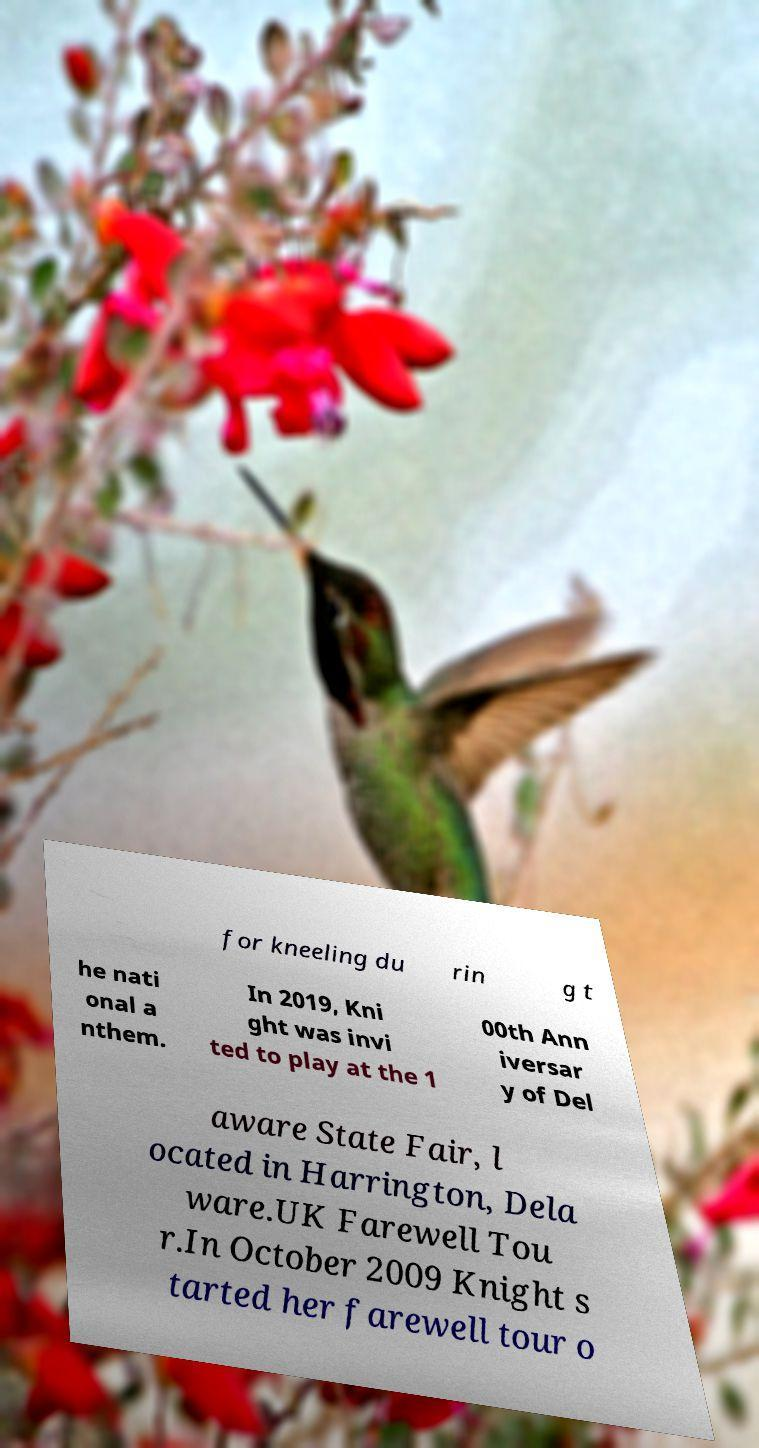I need the written content from this picture converted into text. Can you do that? for kneeling du rin g t he nati onal a nthem. In 2019, Kni ght was invi ted to play at the 1 00th Ann iversar y of Del aware State Fair, l ocated in Harrington, Dela ware.UK Farewell Tou r.In October 2009 Knight s tarted her farewell tour o 